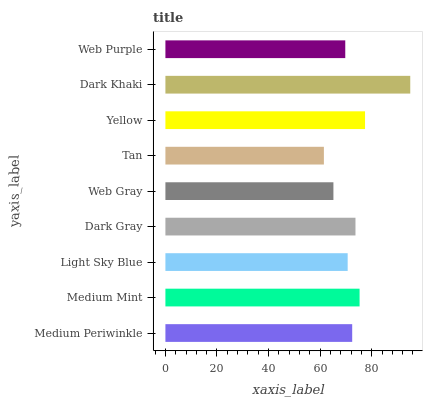Is Tan the minimum?
Answer yes or no. Yes. Is Dark Khaki the maximum?
Answer yes or no. Yes. Is Medium Mint the minimum?
Answer yes or no. No. Is Medium Mint the maximum?
Answer yes or no. No. Is Medium Mint greater than Medium Periwinkle?
Answer yes or no. Yes. Is Medium Periwinkle less than Medium Mint?
Answer yes or no. Yes. Is Medium Periwinkle greater than Medium Mint?
Answer yes or no. No. Is Medium Mint less than Medium Periwinkle?
Answer yes or no. No. Is Medium Periwinkle the high median?
Answer yes or no. Yes. Is Medium Periwinkle the low median?
Answer yes or no. Yes. Is Web Purple the high median?
Answer yes or no. No. Is Medium Mint the low median?
Answer yes or no. No. 